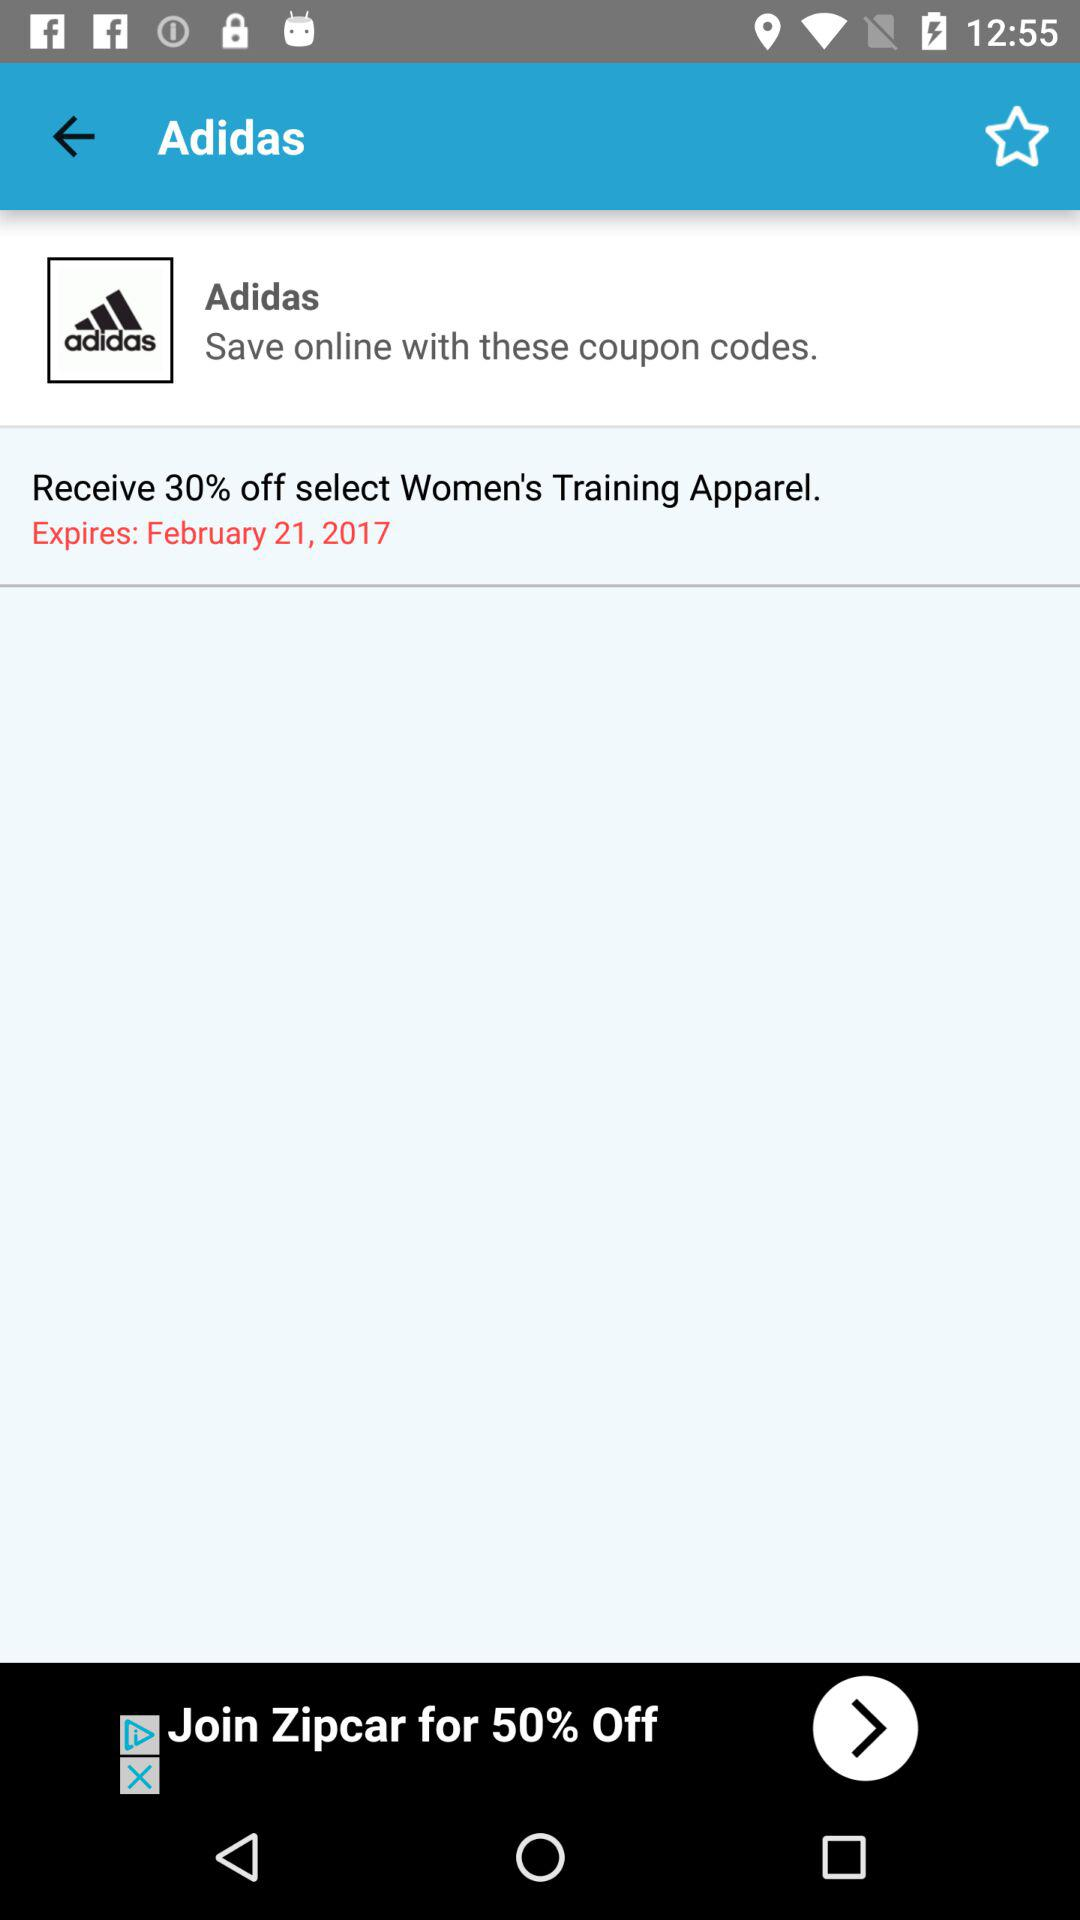What is the application name?
When the provided information is insufficient, respond with <no answer>. <no answer> 